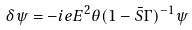Convert formula to latex. <formula><loc_0><loc_0><loc_500><loc_500>\delta \psi = - i e E ^ { 2 } \theta ( 1 - \bar { S } \Gamma ) ^ { - 1 } \psi</formula> 